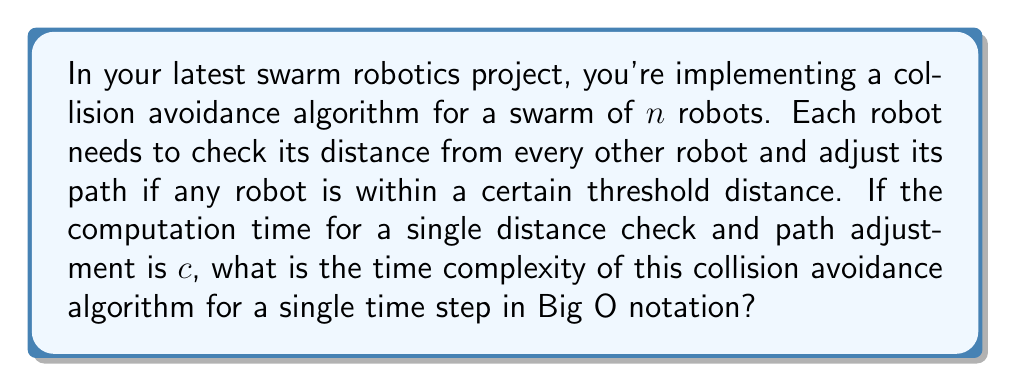Show me your answer to this math problem. Let's approach this step-by-step:

1) First, we need to consider how many distance checks each robot needs to perform. Since each robot needs to check its distance from every other robot, but not itself, each robot performs $(n-1)$ checks.

2) There are $n$ robots in total, so the total number of distance checks is:

   $n * (n-1)$

3) However, this counts each robot-robot interaction twice (Robot A checking Robot B, and Robot B checking Robot A). To avoid this double counting, we need to divide by 2:

   $\frac{n * (n-1)}{2}$

4) Each of these checks takes time $c$, so the total time is:

   $c * \frac{n * (n-1)}{2}$

5) Expanding this:

   $\frac{cn^2 - cn}{2}$

6) In Big O notation, we're concerned with the growth rate as $n$ becomes very large. The $n^2$ term will dominate, and constants (like $c$ and $\frac{1}{2}$) are ignored. The $-cn$ term is also insignificant compared to $cn^2$ for large $n$.

Therefore, the time complexity is $O(n^2)$.
Answer: $O(n^2)$ 